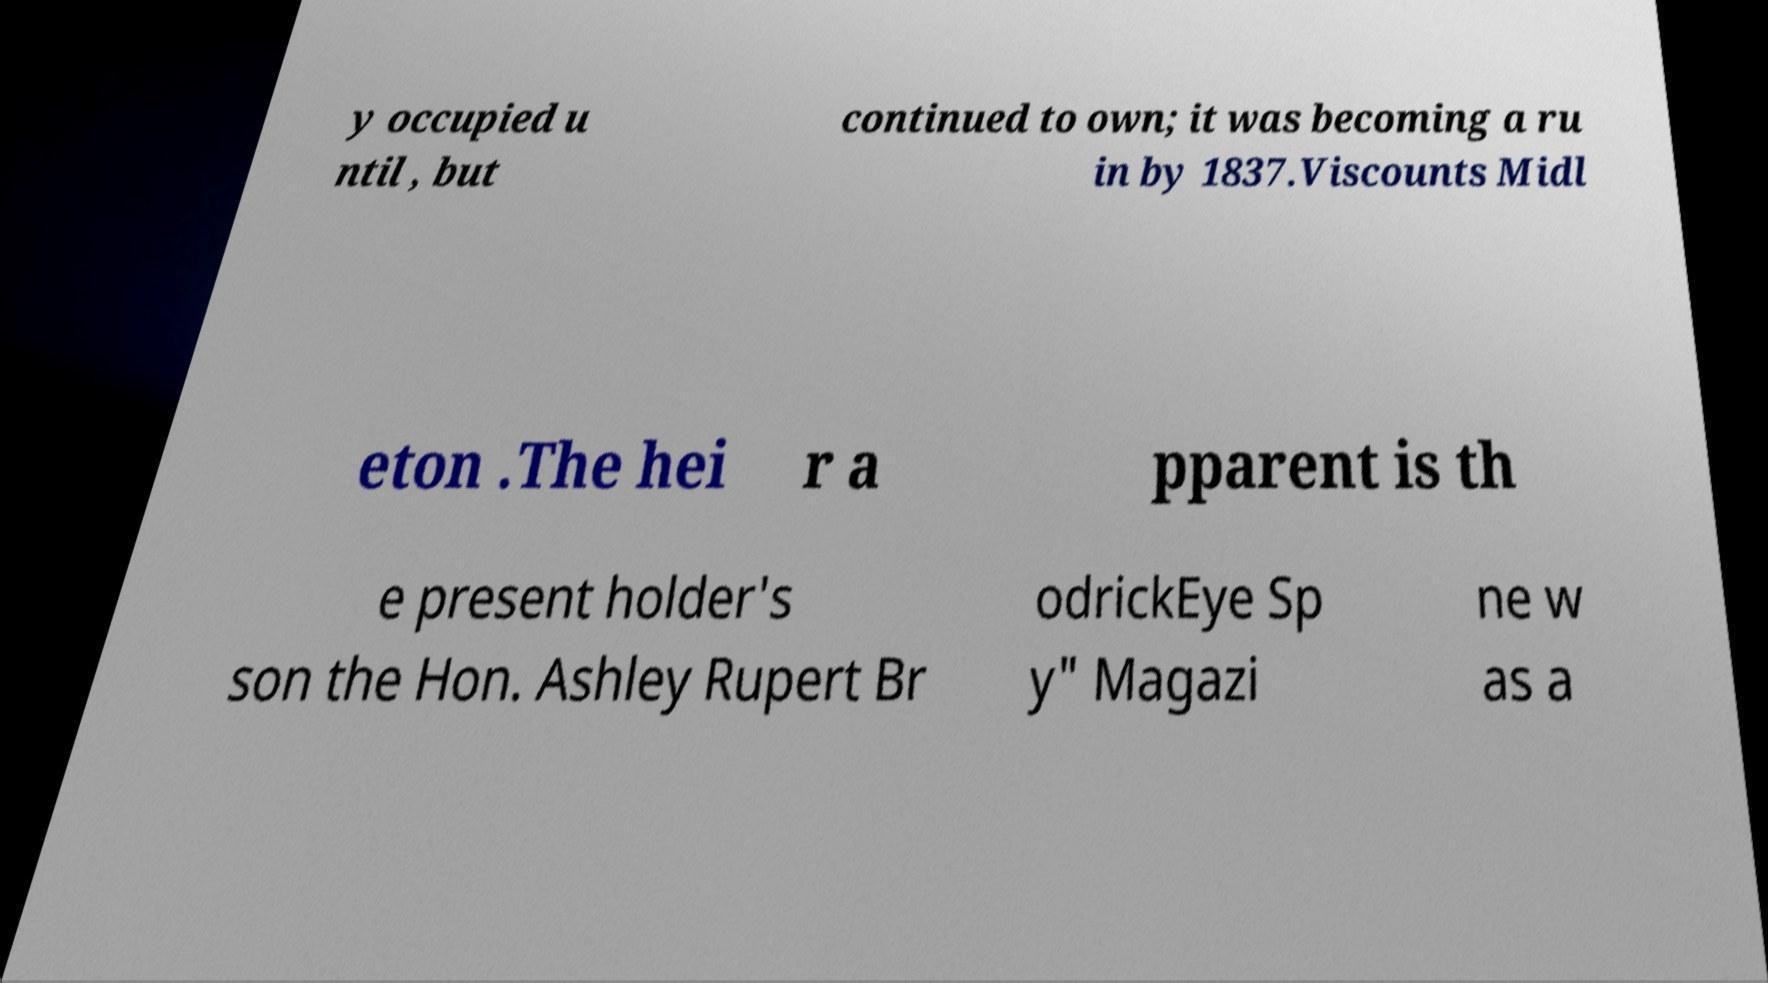For documentation purposes, I need the text within this image transcribed. Could you provide that? y occupied u ntil , but continued to own; it was becoming a ru in by 1837.Viscounts Midl eton .The hei r a pparent is th e present holder's son the Hon. Ashley Rupert Br odrickEye Sp y" Magazi ne w as a 